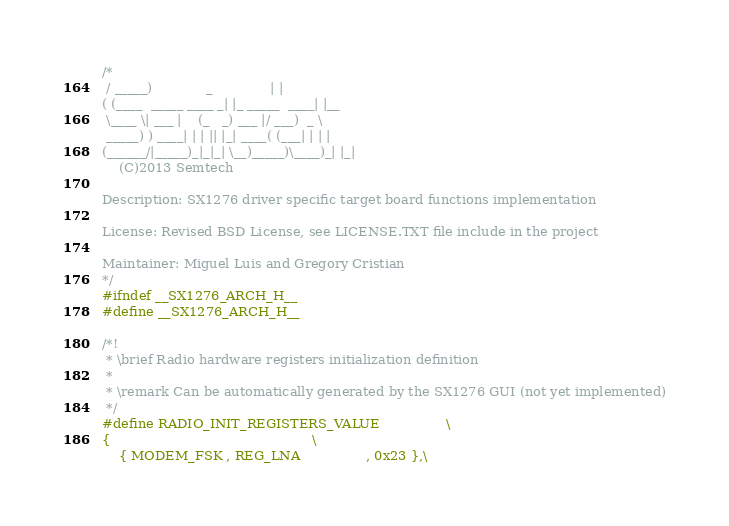Convert code to text. <code><loc_0><loc_0><loc_500><loc_500><_C_>/*
 / _____)             _              | |
( (____  _____ ____ _| |_ _____  ____| |__
 \____ \| ___ |    (_   _) ___ |/ ___)  _ \
 _____) ) ____| | | || |_| ____( (___| | | |
(______/|_____)_|_|_| \__)_____)\____)_| |_|
    (C)2013 Semtech

Description: SX1276 driver specific target board functions implementation

License: Revised BSD License, see LICENSE.TXT file include in the project

Maintainer: Miguel Luis and Gregory Cristian
*/
#ifndef __SX1276_ARCH_H__
#define __SX1276_ARCH_H__

/*!
 * \brief Radio hardware registers initialization definition
 *
 * \remark Can be automatically generated by the SX1276 GUI (not yet implemented)
 */
#define RADIO_INIT_REGISTERS_VALUE                \
{                                                 \
    { MODEM_FSK , REG_LNA                , 0x23 },\</code> 